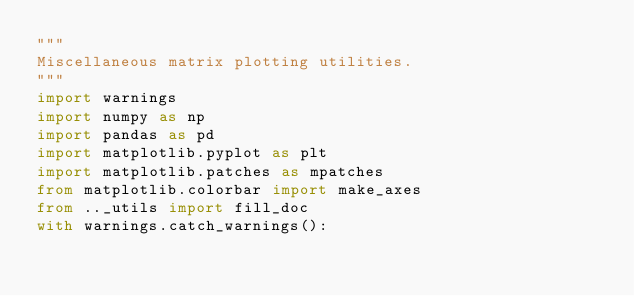<code> <loc_0><loc_0><loc_500><loc_500><_Python_>"""
Miscellaneous matrix plotting utilities.
"""
import warnings
import numpy as np
import pandas as pd
import matplotlib.pyplot as plt
import matplotlib.patches as mpatches
from matplotlib.colorbar import make_axes
from .._utils import fill_doc
with warnings.catch_warnings():</code> 